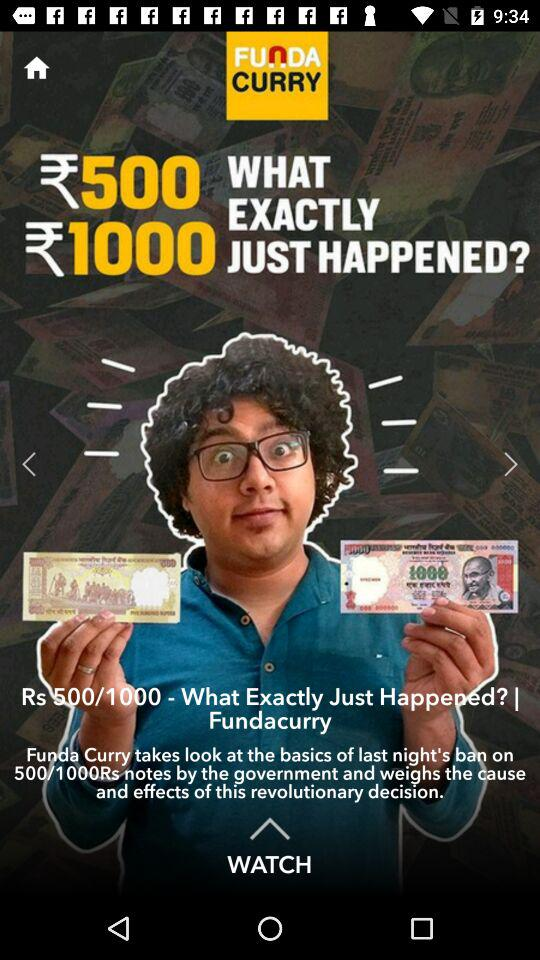What is the channel name? The channel name is "FUNDA CURRY". 